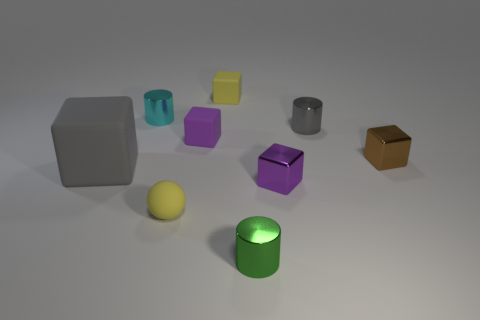Subtract all purple blocks. How many were subtracted if there are1purple blocks left? 1 Subtract all brown cubes. How many cubes are left? 4 Subtract all gray matte blocks. How many blocks are left? 4 Subtract 2 blocks. How many blocks are left? 3 Subtract all brown cubes. Subtract all yellow spheres. How many cubes are left? 4 Subtract all spheres. How many objects are left? 8 Subtract 1 gray cubes. How many objects are left? 8 Subtract all big yellow rubber objects. Subtract all tiny yellow matte cubes. How many objects are left? 8 Add 3 small gray objects. How many small gray objects are left? 4 Add 8 tiny purple metal things. How many tiny purple metal things exist? 9 